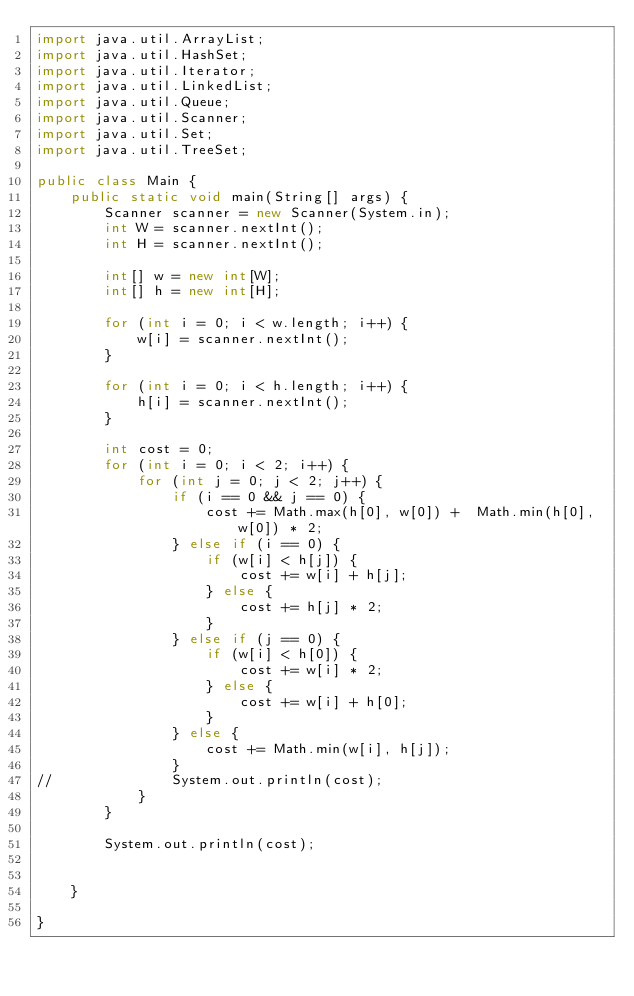Convert code to text. <code><loc_0><loc_0><loc_500><loc_500><_Java_>import java.util.ArrayList;
import java.util.HashSet;
import java.util.Iterator;
import java.util.LinkedList;
import java.util.Queue;
import java.util.Scanner;
import java.util.Set;
import java.util.TreeSet;

public class Main {
	public static void main(String[] args) {
		Scanner scanner = new Scanner(System.in);
		int W = scanner.nextInt();
		int H = scanner.nextInt();
		
		int[] w = new int[W];
		int[] h = new int[H];
		
		for (int i = 0; i < w.length; i++) {
			w[i] = scanner.nextInt();
		}
		
		for (int i = 0; i < h.length; i++) {
			h[i] = scanner.nextInt();
		}
		
		int cost = 0;
		for (int i = 0; i < 2; i++) {
			for (int j = 0; j < 2; j++) {
				if (i == 0 && j == 0) {
					cost += Math.max(h[0], w[0]) +  Math.min(h[0], w[0]) * 2;
				} else if (i == 0) {
					if (w[i] < h[j]) {
						cost += w[i] + h[j];
					} else {
						cost += h[j] * 2; 
					}
				} else if (j == 0) {
					if (w[i] < h[0]) {
						cost += w[i] * 2;
					} else {
						cost += w[i] + h[0];
					}
				} else {
					cost += Math.min(w[i], h[j]);
				}
//				System.out.println(cost);
			}
		}
		
		System.out.println(cost);
		
		
	}

}</code> 